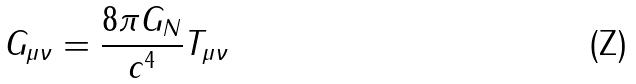<formula> <loc_0><loc_0><loc_500><loc_500>G _ { \mu \nu } = \frac { 8 \pi G _ { N } } { c ^ { 4 } } T _ { \mu \nu }</formula> 